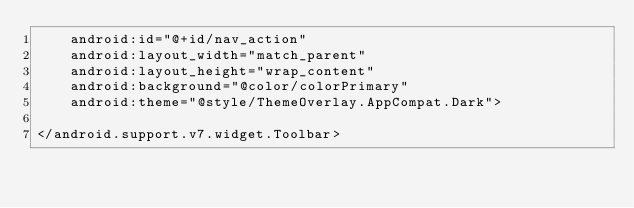<code> <loc_0><loc_0><loc_500><loc_500><_XML_>    android:id="@+id/nav_action"
    android:layout_width="match_parent"
    android:layout_height="wrap_content"
    android:background="@color/colorPrimary"
    android:theme="@style/ThemeOverlay.AppCompat.Dark">

</android.support.v7.widget.Toolbar></code> 